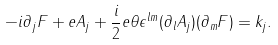<formula> <loc_0><loc_0><loc_500><loc_500>- i \partial _ { j } F + e A _ { j } + \frac { i } { 2 } e \theta \epsilon ^ { l m } ( \partial _ { l } A _ { j } ) ( \partial _ { m } F ) = k _ { j } .</formula> 